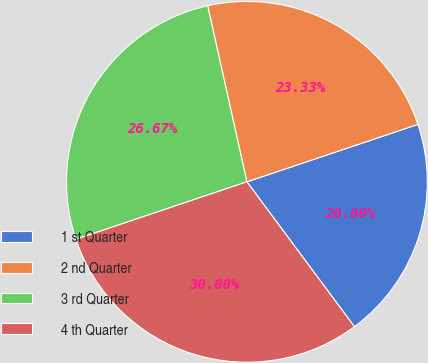Convert chart to OTSL. <chart><loc_0><loc_0><loc_500><loc_500><pie_chart><fcel>1 st Quarter<fcel>2 nd Quarter<fcel>3 rd Quarter<fcel>4 th Quarter<nl><fcel>20.0%<fcel>23.33%<fcel>26.67%<fcel>30.0%<nl></chart> 